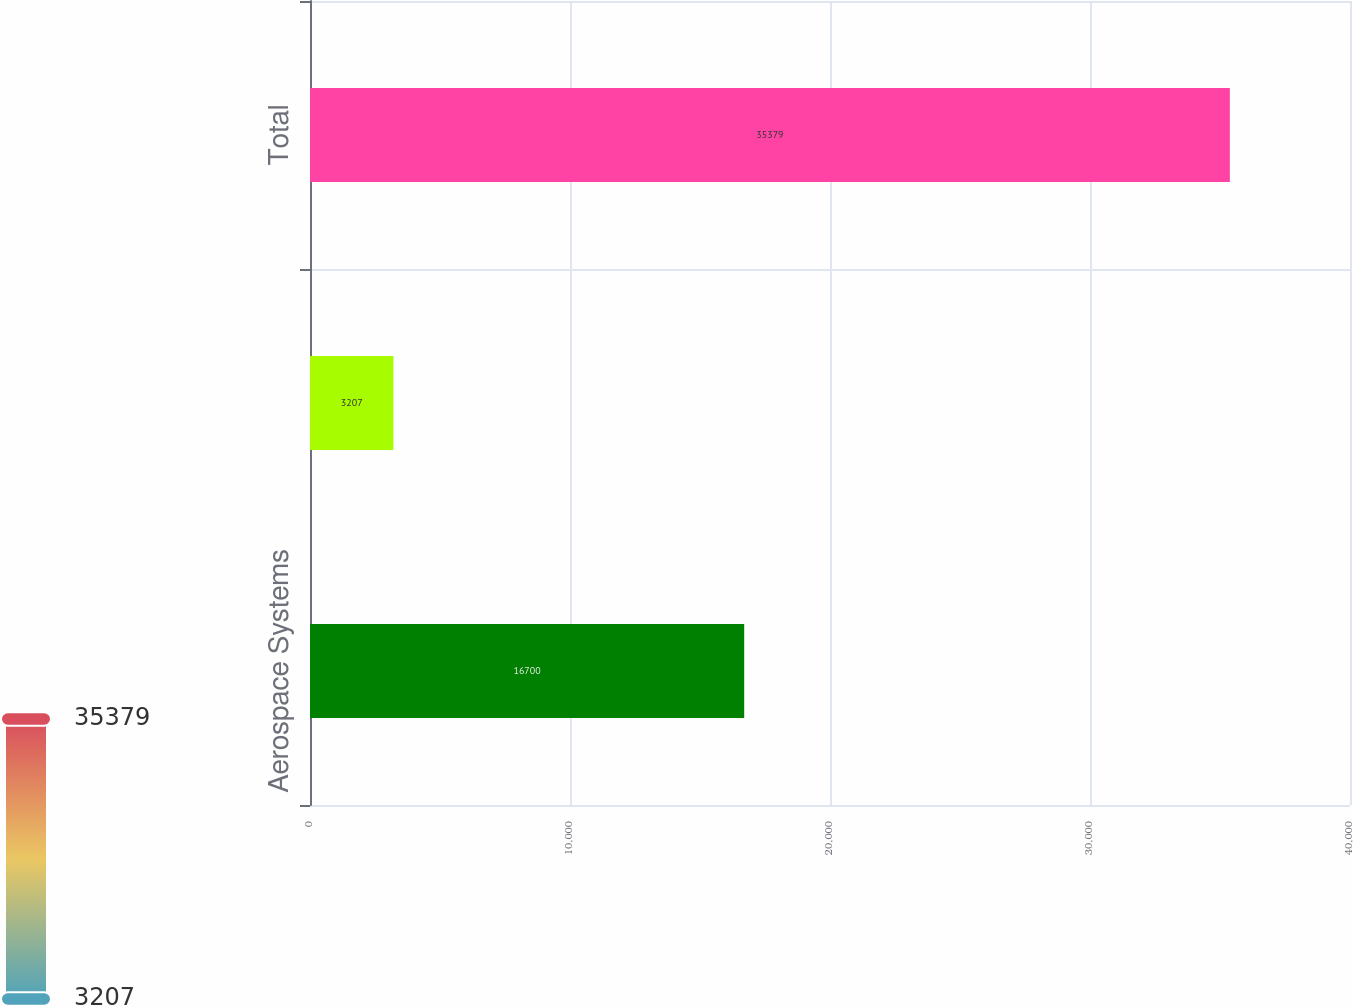Convert chart to OTSL. <chart><loc_0><loc_0><loc_500><loc_500><bar_chart><fcel>Aerospace Systems<fcel>Technology Services<fcel>Total<nl><fcel>16700<fcel>3207<fcel>35379<nl></chart> 